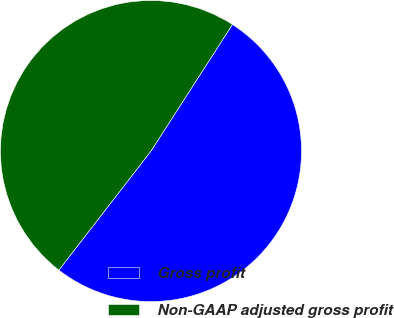Convert chart to OTSL. <chart><loc_0><loc_0><loc_500><loc_500><pie_chart><fcel>Gross profit<fcel>Non-GAAP adjusted gross profit<nl><fcel>51.38%<fcel>48.62%<nl></chart> 